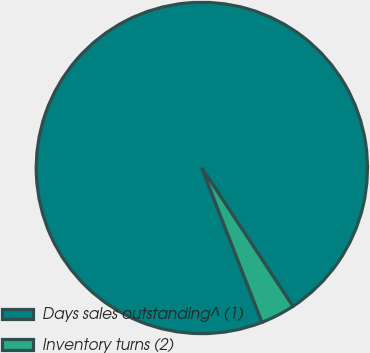Convert chart to OTSL. <chart><loc_0><loc_0><loc_500><loc_500><pie_chart><fcel>Days sales outstanding^ (1)<fcel>Inventory turns (2)<nl><fcel>96.65%<fcel>3.35%<nl></chart> 